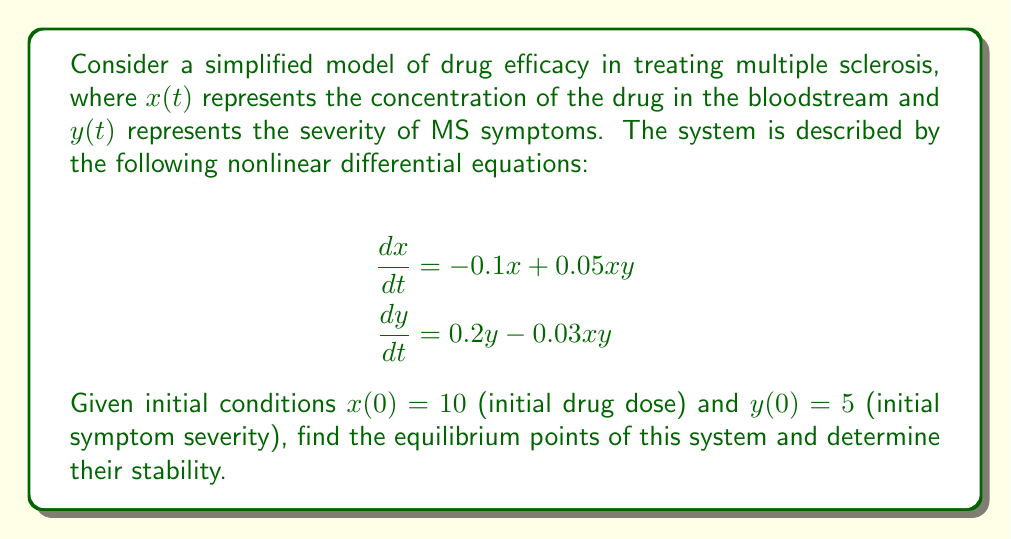Give your solution to this math problem. 1) To find the equilibrium points, set both derivatives to zero:

   $$-0.1x + 0.05xy = 0$$
   $$0.2y - 0.03xy = 0$$

2) From the second equation:
   $$0.2y - 0.03xy = 0$$
   $$y(0.2 - 0.03x) = 0$$
   
   This gives us two possibilities: $y = 0$ or $0.2 - 0.03x = 0$

3) If $y = 0$, substituting into the first equation:
   $$-0.1x = 0$$
   $$x = 0$$
   
   So $(0,0)$ is an equilibrium point.

4) If $0.2 - 0.03x = 0$, then:
   $$x = \frac{0.2}{0.03} \approx 6.67$$
   
   Substituting this into the first equation:
   $$-0.1(6.67) + 0.05(6.67)y = 0$$
   $$-0.667 + 0.3335y = 0$$
   $$y = 2$$

   So $(6.67, 2)$ is another equilibrium point.

5) To determine stability, we need to find the Jacobian matrix:

   $$J = \begin{bmatrix}
   \frac{\partial f_1}{\partial x} & \frac{\partial f_1}{\partial y} \\
   \frac{\partial f_2}{\partial x} & \frac{\partial f_2}{\partial y}
   \end{bmatrix} = \begin{bmatrix}
   -0.1 + 0.05y & 0.05x \\
   -0.03y & 0.2 - 0.03x
   \end{bmatrix}$$

6) For $(0,0)$:
   $$J_{(0,0)} = \begin{bmatrix}
   -0.1 & 0 \\
   0 & 0.2
   \end{bmatrix}$$
   
   Eigenvalues: $\lambda_1 = -0.1$, $\lambda_2 = 0.2$
   Since one eigenvalue is positive, $(0,0)$ is an unstable saddle point.

7) For $(6.67, 2)$:
   $$J_{(6.67,2)} = \begin{bmatrix}
   0 & 0.3335 \\
   -0.06 & 0
   \end{bmatrix}$$
   
   Eigenvalues: $\lambda = \pm i\sqrt{0.3335 \cdot 0.06} \approx \pm 0.1414i$
   Since both eigenvalues are purely imaginary, $(6.67, 2)$ is a center (neutrally stable).
Answer: Equilibrium points: $(0,0)$ (unstable saddle) and $(6.67, 2)$ (neutrally stable center). 